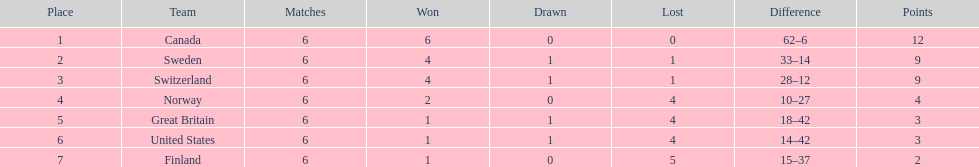How many teams accomplished no less than 4 triumphs? 3. 